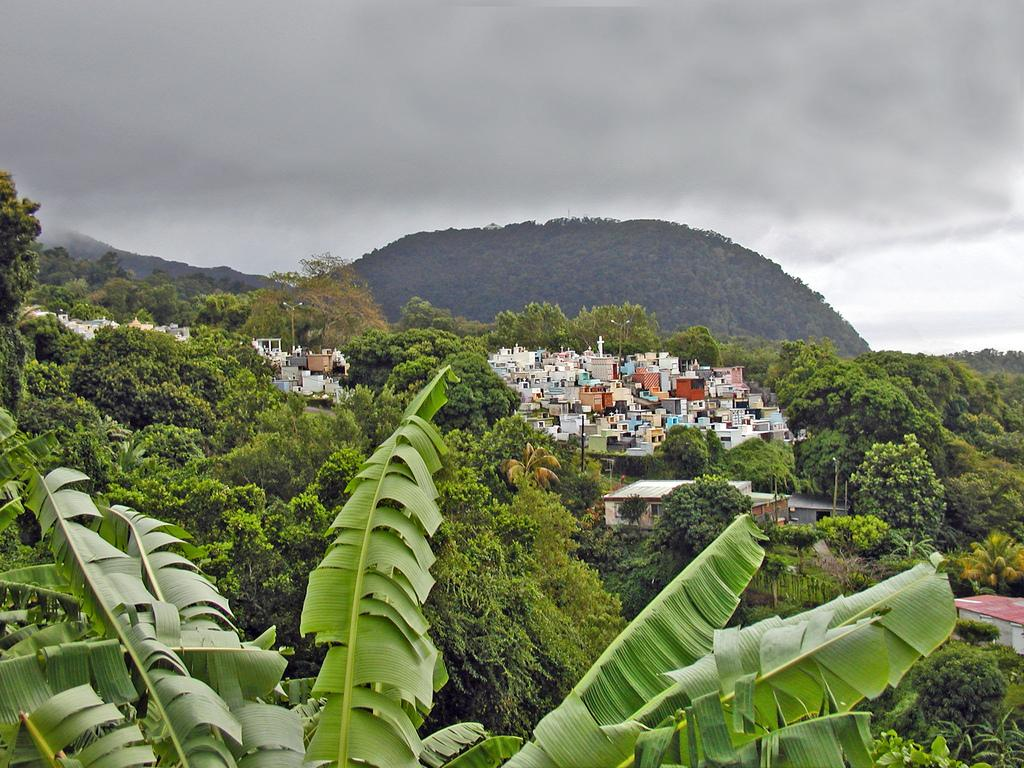What type of vegetation can be seen in the image? There are trees in the image. What type of structures are present in the image? There are houses in the image. What geographical feature is visible in the image? There is a hill in the image. What is visible at the top of the image? The sky is visible at the top of the image. What group of people can be seen expressing their desire for wilderness in the image? There is no group of people or expression of desire for wilderness present in the image. 